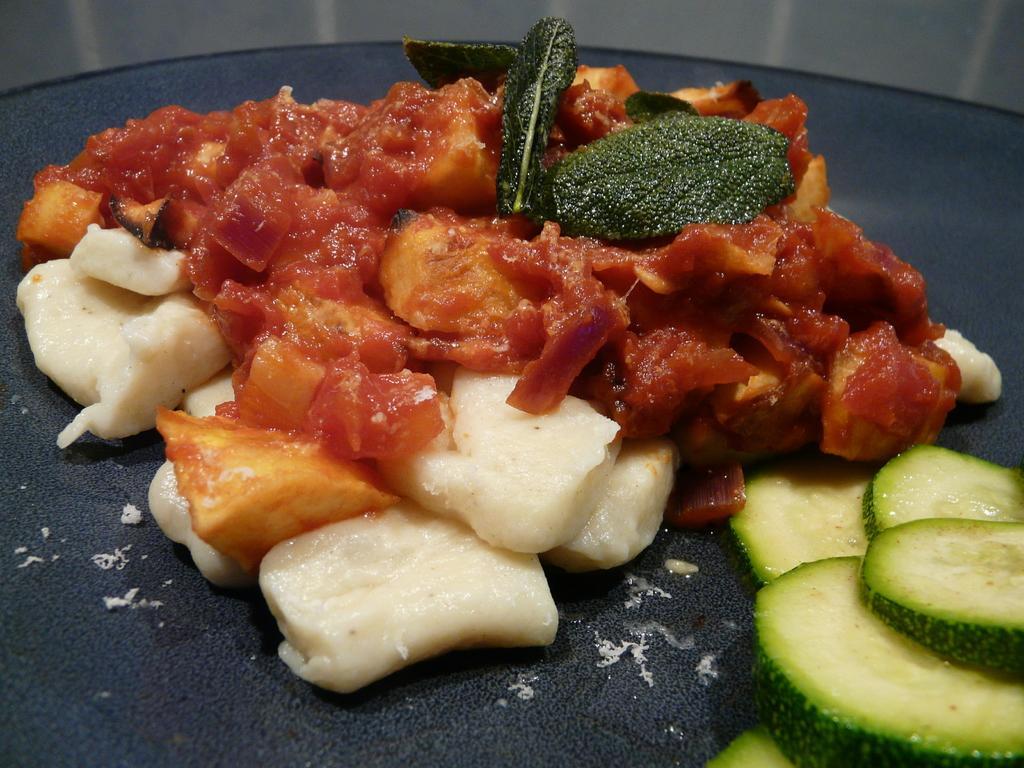Please provide a concise description of this image. In the picture I can see some food items are placed on the black color surface. 